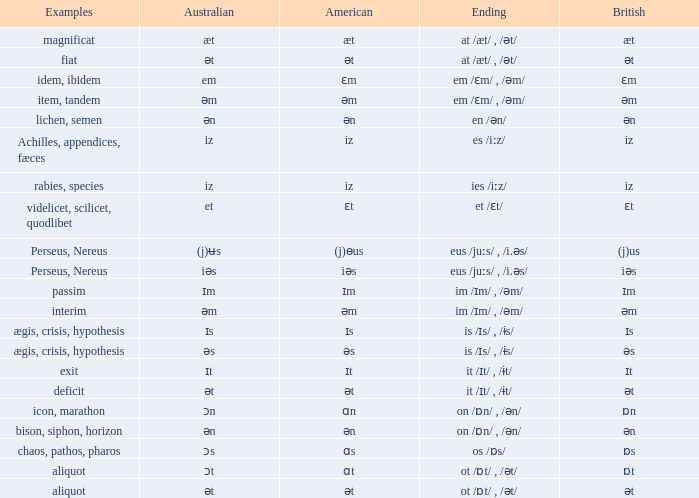Which Australian has British of ɒs? Ɔs. 